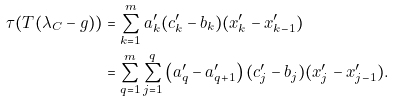<formula> <loc_0><loc_0><loc_500><loc_500>\tau ( T ( \lambda _ { C } - g ) ) & = \sum ^ { m } _ { k = 1 } a ^ { \prime } _ { k } ( c ^ { \prime } _ { k } - b _ { k } ) ( x ^ { \prime } _ { k } - x ^ { \prime } _ { k - 1 } ) \\ & = \sum ^ { m } _ { q = 1 } \sum ^ { q } _ { j = 1 } \left ( a ^ { \prime } _ { q } - a ^ { \prime } _ { q + 1 } \right ) ( c ^ { \prime } _ { j } - b _ { j } ) ( x ^ { \prime } _ { j } - x ^ { \prime } _ { j - 1 } ) .</formula> 